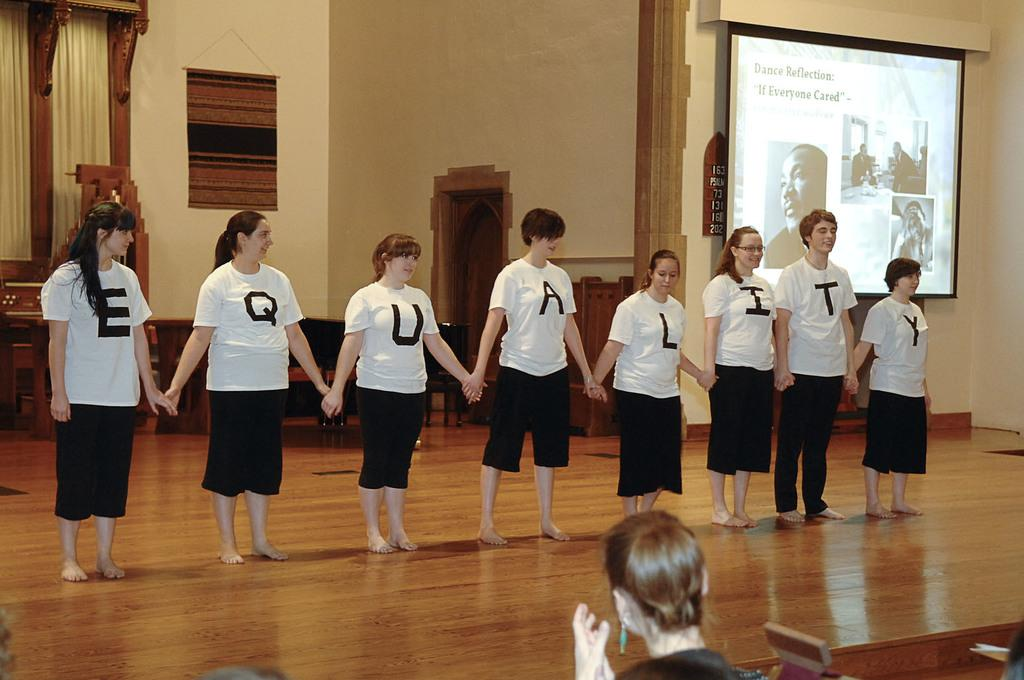What is happening in the foreground of the image? There is a person in the foreground. What can be seen in the background of the image? There is a screen and a window in the background. What is associated with the window in the background? There are curtains associated with the window. How many people are visible in the image? There is a group of people standing on the ground, but we cannot determine the exact number from the provided facts. Can you tell me how many chess pieces are on the sink in the image? There is no sink or chess pieces present in the image. What type of face can be seen on the person in the foreground? The provided facts do not mention any details about the person's face, so we cannot determine the type of face from the image. 